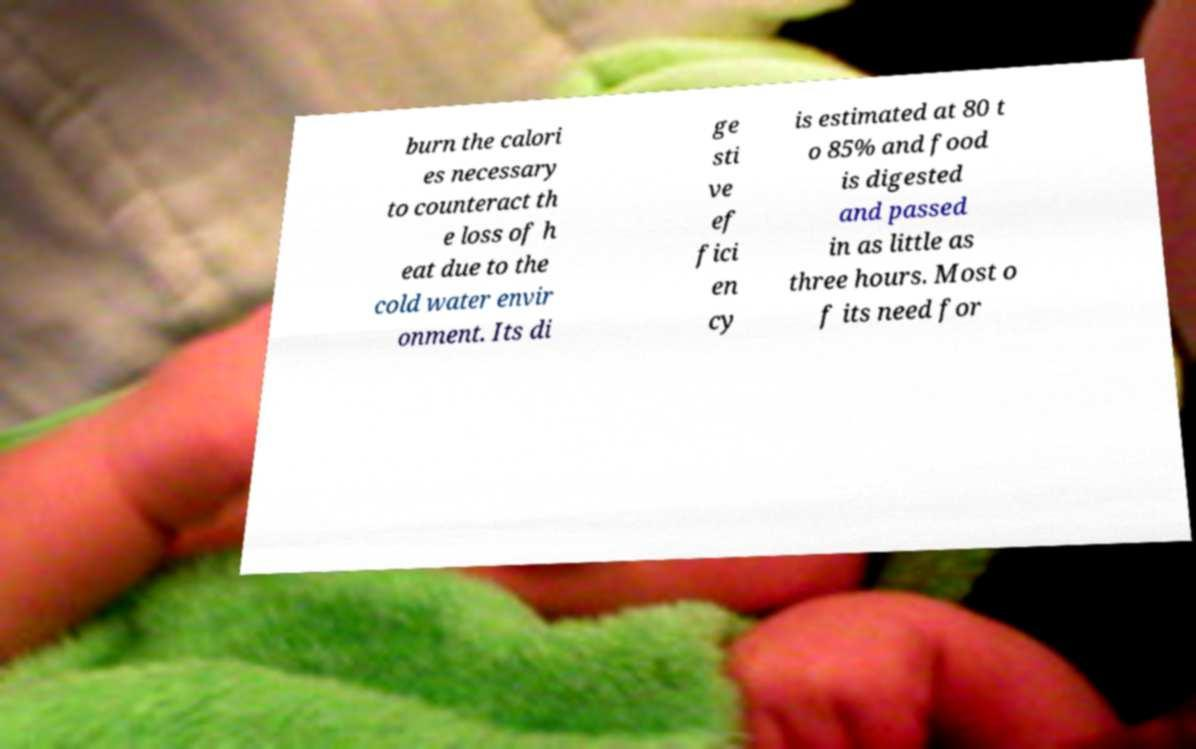Could you extract and type out the text from this image? burn the calori es necessary to counteract th e loss of h eat due to the cold water envir onment. Its di ge sti ve ef fici en cy is estimated at 80 t o 85% and food is digested and passed in as little as three hours. Most o f its need for 